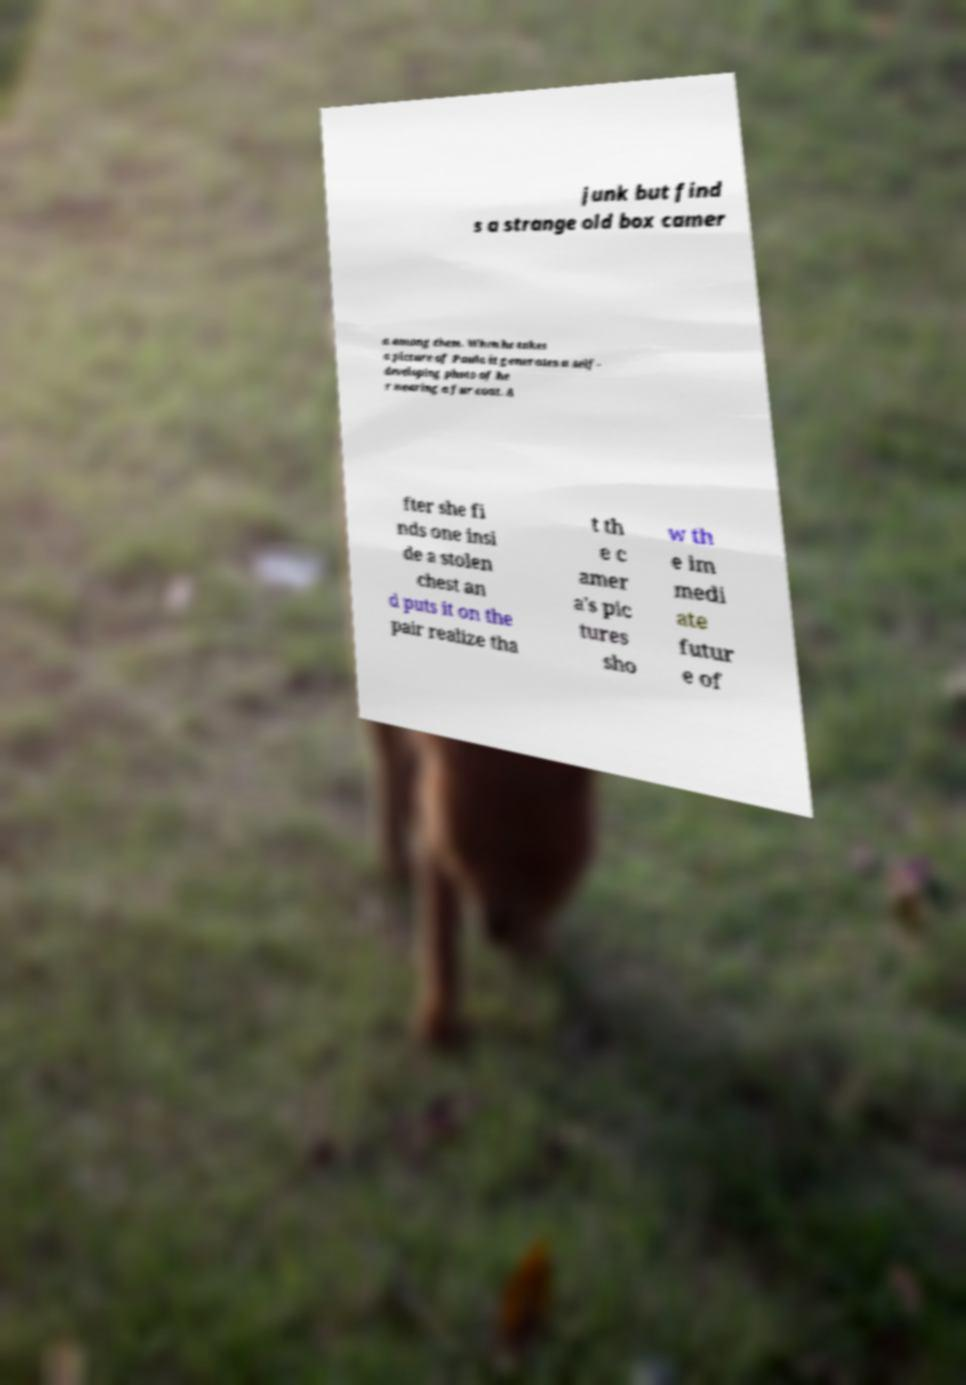Can you read and provide the text displayed in the image?This photo seems to have some interesting text. Can you extract and type it out for me? junk but find s a strange old box camer a among them. When he takes a picture of Paula it generates a self- developing photo of he r wearing a fur coat. A fter she fi nds one insi de a stolen chest an d puts it on the pair realize tha t th e c amer a's pic tures sho w th e im medi ate futur e of 